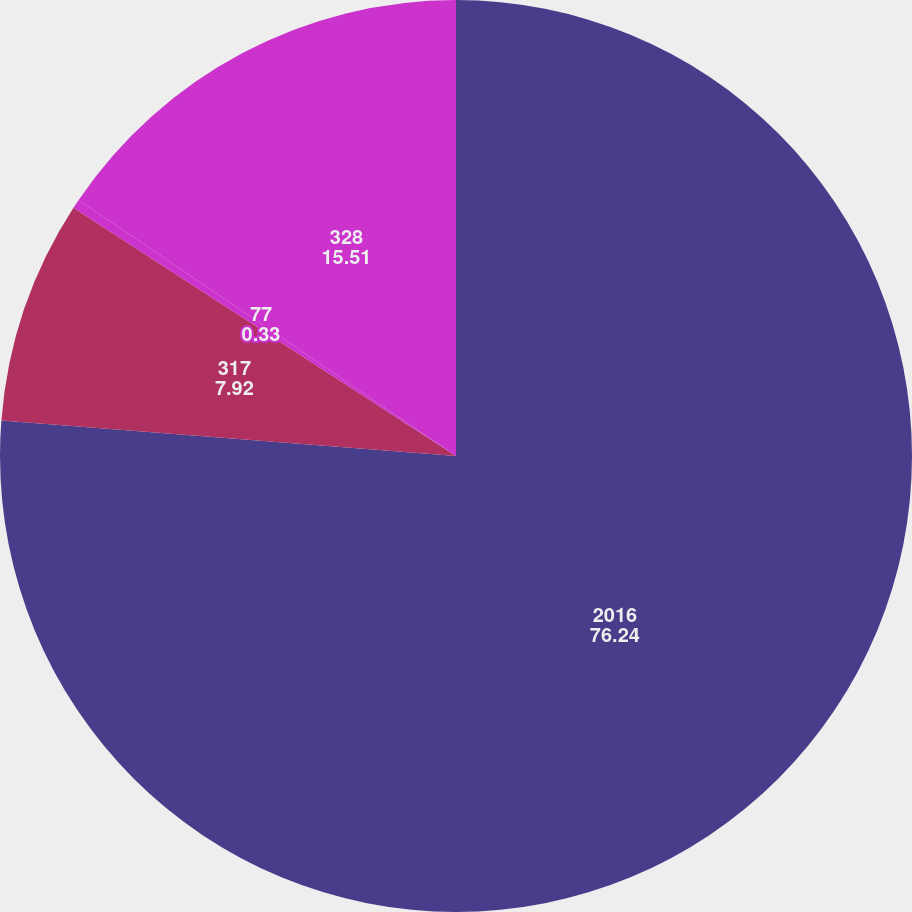Convert chart. <chart><loc_0><loc_0><loc_500><loc_500><pie_chart><fcel>2016<fcel>317<fcel>77<fcel>328<nl><fcel>76.24%<fcel>7.92%<fcel>0.33%<fcel>15.51%<nl></chart> 